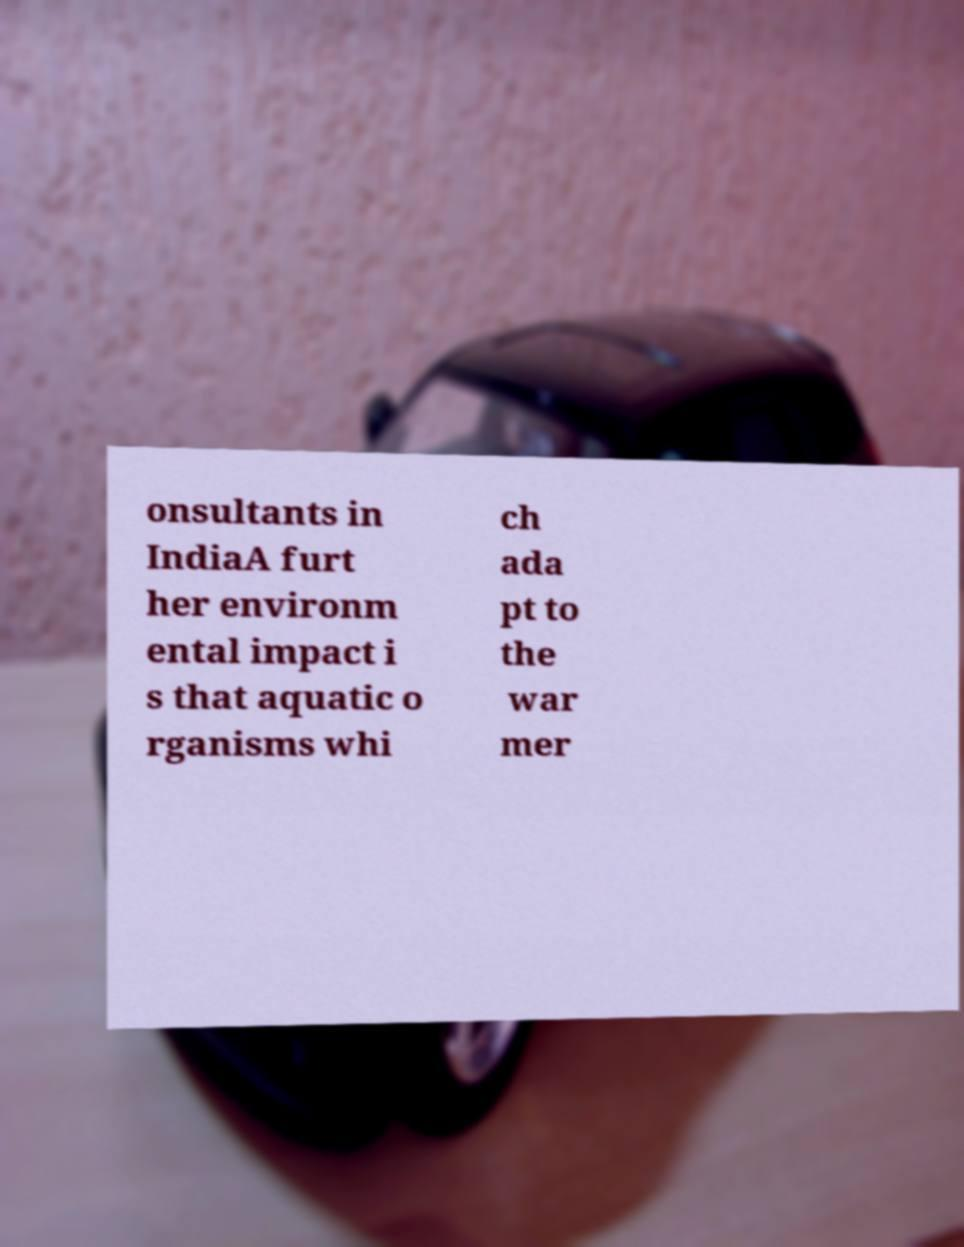Can you accurately transcribe the text from the provided image for me? onsultants in IndiaA furt her environm ental impact i s that aquatic o rganisms whi ch ada pt to the war mer 